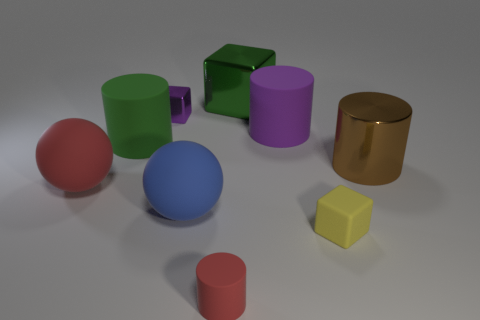Subtract all tiny cubes. How many cubes are left? 1 Subtract 2 cylinders. How many cylinders are left? 2 Subtract all green cylinders. How many cylinders are left? 3 Subtract all spheres. How many objects are left? 7 Subtract all green spheres. How many green cubes are left? 1 Subtract all large brown cubes. Subtract all spheres. How many objects are left? 7 Add 3 big balls. How many big balls are left? 5 Add 9 blue rubber things. How many blue rubber things exist? 10 Subtract 0 gray spheres. How many objects are left? 9 Subtract all gray cylinders. Subtract all green balls. How many cylinders are left? 4 